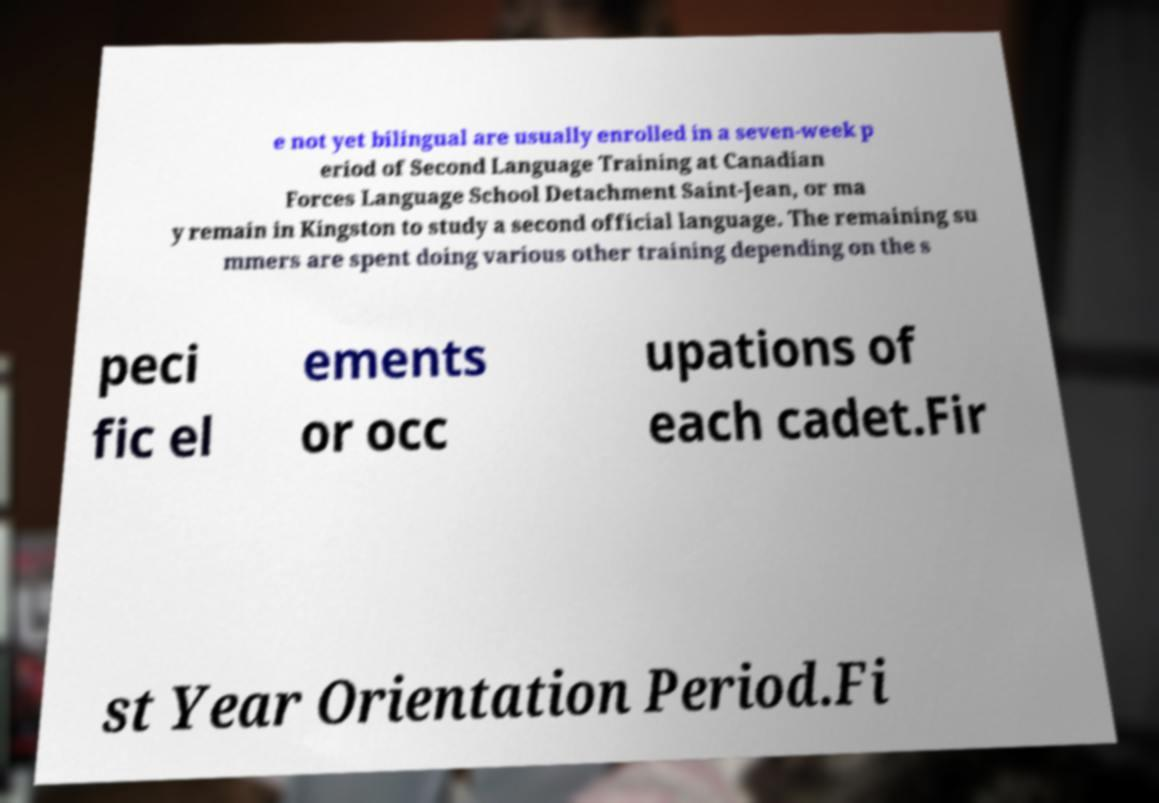What messages or text are displayed in this image? I need them in a readable, typed format. e not yet bilingual are usually enrolled in a seven-week p eriod of Second Language Training at Canadian Forces Language School Detachment Saint-Jean, or ma y remain in Kingston to study a second official language. The remaining su mmers are spent doing various other training depending on the s peci fic el ements or occ upations of each cadet.Fir st Year Orientation Period.Fi 